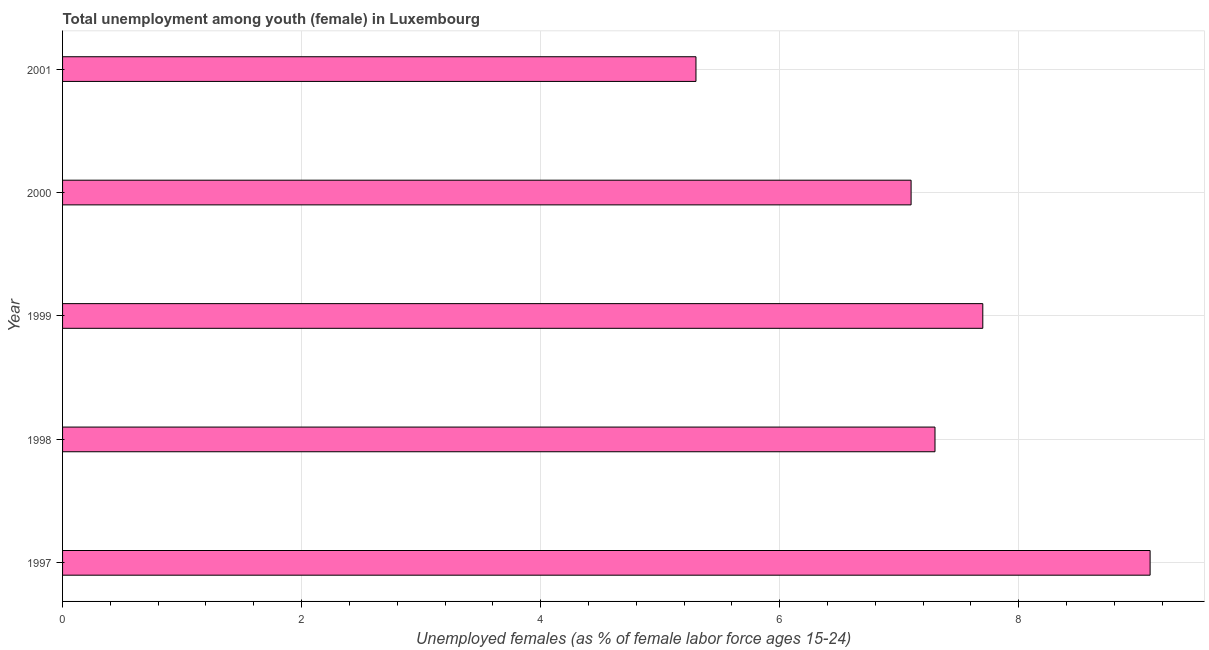Does the graph contain any zero values?
Your answer should be very brief. No. What is the title of the graph?
Make the answer very short. Total unemployment among youth (female) in Luxembourg. What is the label or title of the X-axis?
Provide a short and direct response. Unemployed females (as % of female labor force ages 15-24). What is the label or title of the Y-axis?
Keep it short and to the point. Year. What is the unemployed female youth population in 2000?
Ensure brevity in your answer.  7.1. Across all years, what is the maximum unemployed female youth population?
Provide a succinct answer. 9.1. Across all years, what is the minimum unemployed female youth population?
Ensure brevity in your answer.  5.3. In which year was the unemployed female youth population maximum?
Your answer should be compact. 1997. What is the sum of the unemployed female youth population?
Offer a very short reply. 36.5. What is the difference between the unemployed female youth population in 2000 and 2001?
Provide a succinct answer. 1.8. What is the average unemployed female youth population per year?
Offer a very short reply. 7.3. What is the median unemployed female youth population?
Give a very brief answer. 7.3. In how many years, is the unemployed female youth population greater than 1.2 %?
Your answer should be very brief. 5. What is the ratio of the unemployed female youth population in 1997 to that in 1999?
Your answer should be compact. 1.18. Is the difference between the unemployed female youth population in 1997 and 2000 greater than the difference between any two years?
Keep it short and to the point. No. What is the difference between the highest and the second highest unemployed female youth population?
Keep it short and to the point. 1.4. Is the sum of the unemployed female youth population in 1997 and 1998 greater than the maximum unemployed female youth population across all years?
Provide a short and direct response. Yes. What is the difference between the highest and the lowest unemployed female youth population?
Give a very brief answer. 3.8. How many bars are there?
Provide a succinct answer. 5. Are all the bars in the graph horizontal?
Keep it short and to the point. Yes. How many years are there in the graph?
Offer a terse response. 5. What is the difference between two consecutive major ticks on the X-axis?
Provide a succinct answer. 2. Are the values on the major ticks of X-axis written in scientific E-notation?
Offer a very short reply. No. What is the Unemployed females (as % of female labor force ages 15-24) in 1997?
Provide a short and direct response. 9.1. What is the Unemployed females (as % of female labor force ages 15-24) in 1998?
Ensure brevity in your answer.  7.3. What is the Unemployed females (as % of female labor force ages 15-24) in 1999?
Your response must be concise. 7.7. What is the Unemployed females (as % of female labor force ages 15-24) in 2000?
Give a very brief answer. 7.1. What is the Unemployed females (as % of female labor force ages 15-24) of 2001?
Your answer should be compact. 5.3. What is the difference between the Unemployed females (as % of female labor force ages 15-24) in 1997 and 1998?
Keep it short and to the point. 1.8. What is the difference between the Unemployed females (as % of female labor force ages 15-24) in 1997 and 1999?
Provide a succinct answer. 1.4. What is the difference between the Unemployed females (as % of female labor force ages 15-24) in 1997 and 2001?
Your response must be concise. 3.8. What is the difference between the Unemployed females (as % of female labor force ages 15-24) in 1998 and 2000?
Ensure brevity in your answer.  0.2. What is the difference between the Unemployed females (as % of female labor force ages 15-24) in 1998 and 2001?
Make the answer very short. 2. What is the difference between the Unemployed females (as % of female labor force ages 15-24) in 2000 and 2001?
Your answer should be very brief. 1.8. What is the ratio of the Unemployed females (as % of female labor force ages 15-24) in 1997 to that in 1998?
Provide a short and direct response. 1.25. What is the ratio of the Unemployed females (as % of female labor force ages 15-24) in 1997 to that in 1999?
Offer a terse response. 1.18. What is the ratio of the Unemployed females (as % of female labor force ages 15-24) in 1997 to that in 2000?
Your answer should be compact. 1.28. What is the ratio of the Unemployed females (as % of female labor force ages 15-24) in 1997 to that in 2001?
Offer a very short reply. 1.72. What is the ratio of the Unemployed females (as % of female labor force ages 15-24) in 1998 to that in 1999?
Your answer should be very brief. 0.95. What is the ratio of the Unemployed females (as % of female labor force ages 15-24) in 1998 to that in 2000?
Your answer should be compact. 1.03. What is the ratio of the Unemployed females (as % of female labor force ages 15-24) in 1998 to that in 2001?
Ensure brevity in your answer.  1.38. What is the ratio of the Unemployed females (as % of female labor force ages 15-24) in 1999 to that in 2000?
Provide a succinct answer. 1.08. What is the ratio of the Unemployed females (as % of female labor force ages 15-24) in 1999 to that in 2001?
Provide a short and direct response. 1.45. What is the ratio of the Unemployed females (as % of female labor force ages 15-24) in 2000 to that in 2001?
Ensure brevity in your answer.  1.34. 